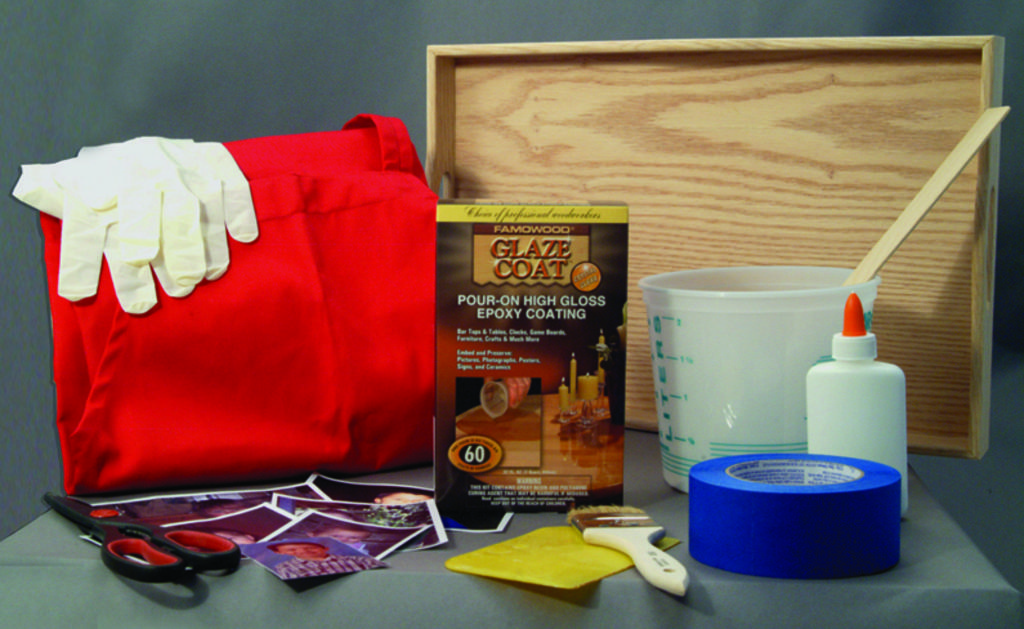Please provide a concise description of this image. In this image there is a table having a scissor, photos, brush, tape, bottle, box, bag, tray are on it. Bag is having gloves are on it. 